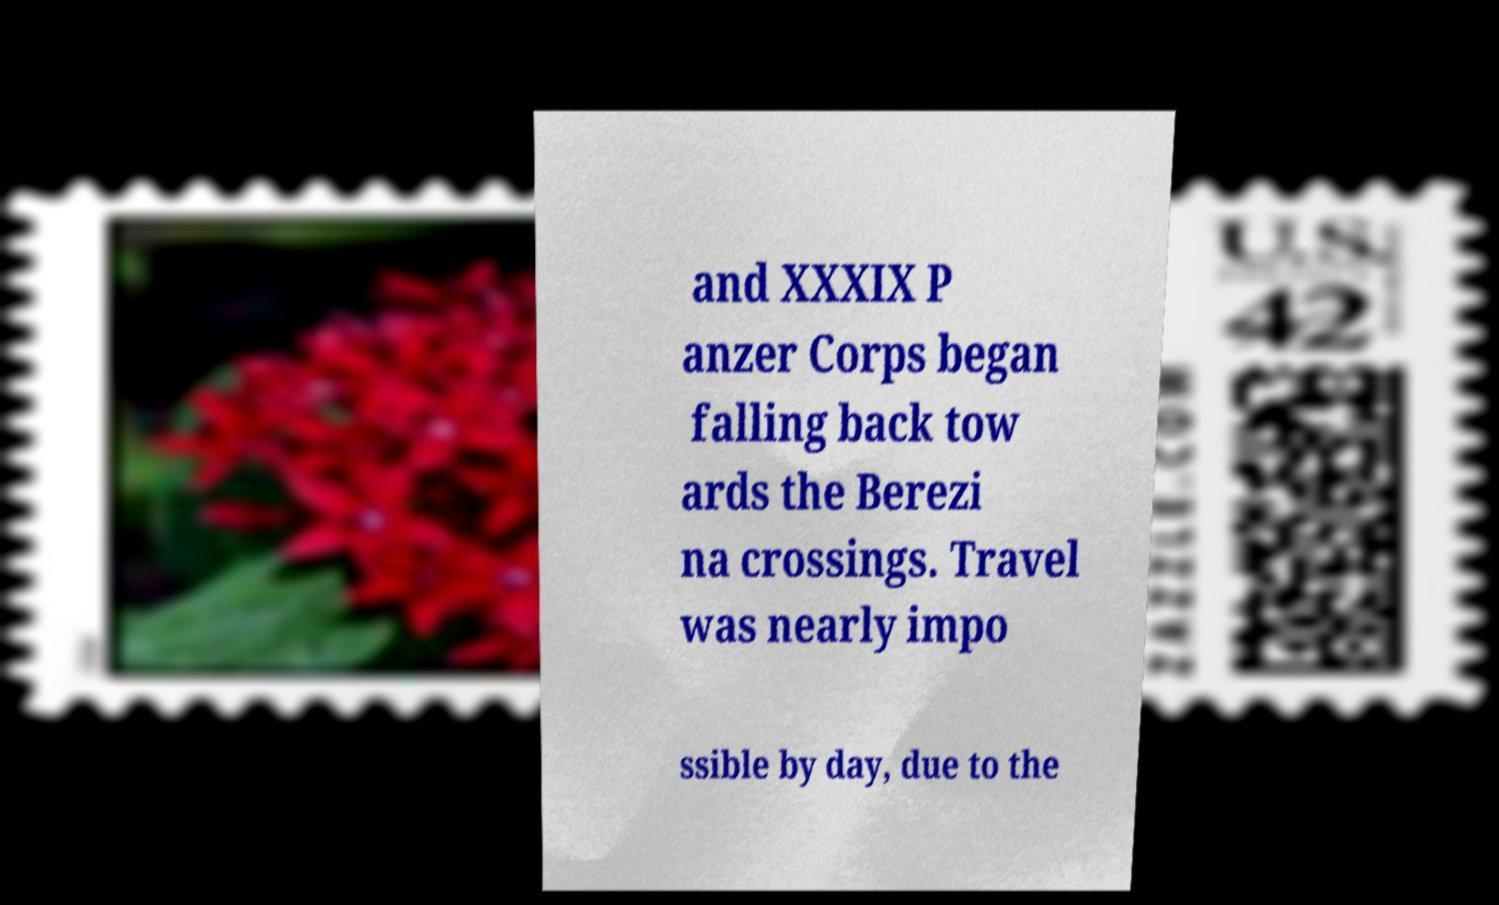Please identify and transcribe the text found in this image. and XXXIX P anzer Corps began falling back tow ards the Berezi na crossings. Travel was nearly impo ssible by day, due to the 